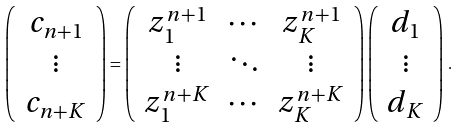Convert formula to latex. <formula><loc_0><loc_0><loc_500><loc_500>\left ( \begin{array} { c } c _ { n + 1 } \\ \vdots \\ c _ { n + K } \end{array} \right ) = \left ( \begin{array} { c c c } z _ { 1 } ^ { n + 1 } & \cdots & z _ { K } ^ { n + 1 } \\ \vdots & \ddots & \vdots \\ z _ { 1 } ^ { n + K } & \cdots & z _ { K } ^ { n + K } \end{array} \right ) \left ( \begin{array} { c } d _ { 1 } \\ \vdots \\ d _ { K } \end{array} \right ) \, .</formula> 